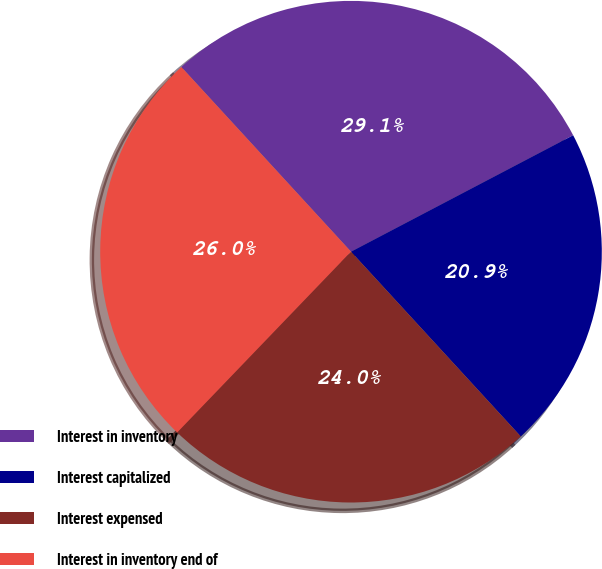Convert chart. <chart><loc_0><loc_0><loc_500><loc_500><pie_chart><fcel>Interest in inventory<fcel>Interest capitalized<fcel>Interest expensed<fcel>Interest in inventory end of<nl><fcel>29.14%<fcel>20.86%<fcel>24.01%<fcel>25.99%<nl></chart> 